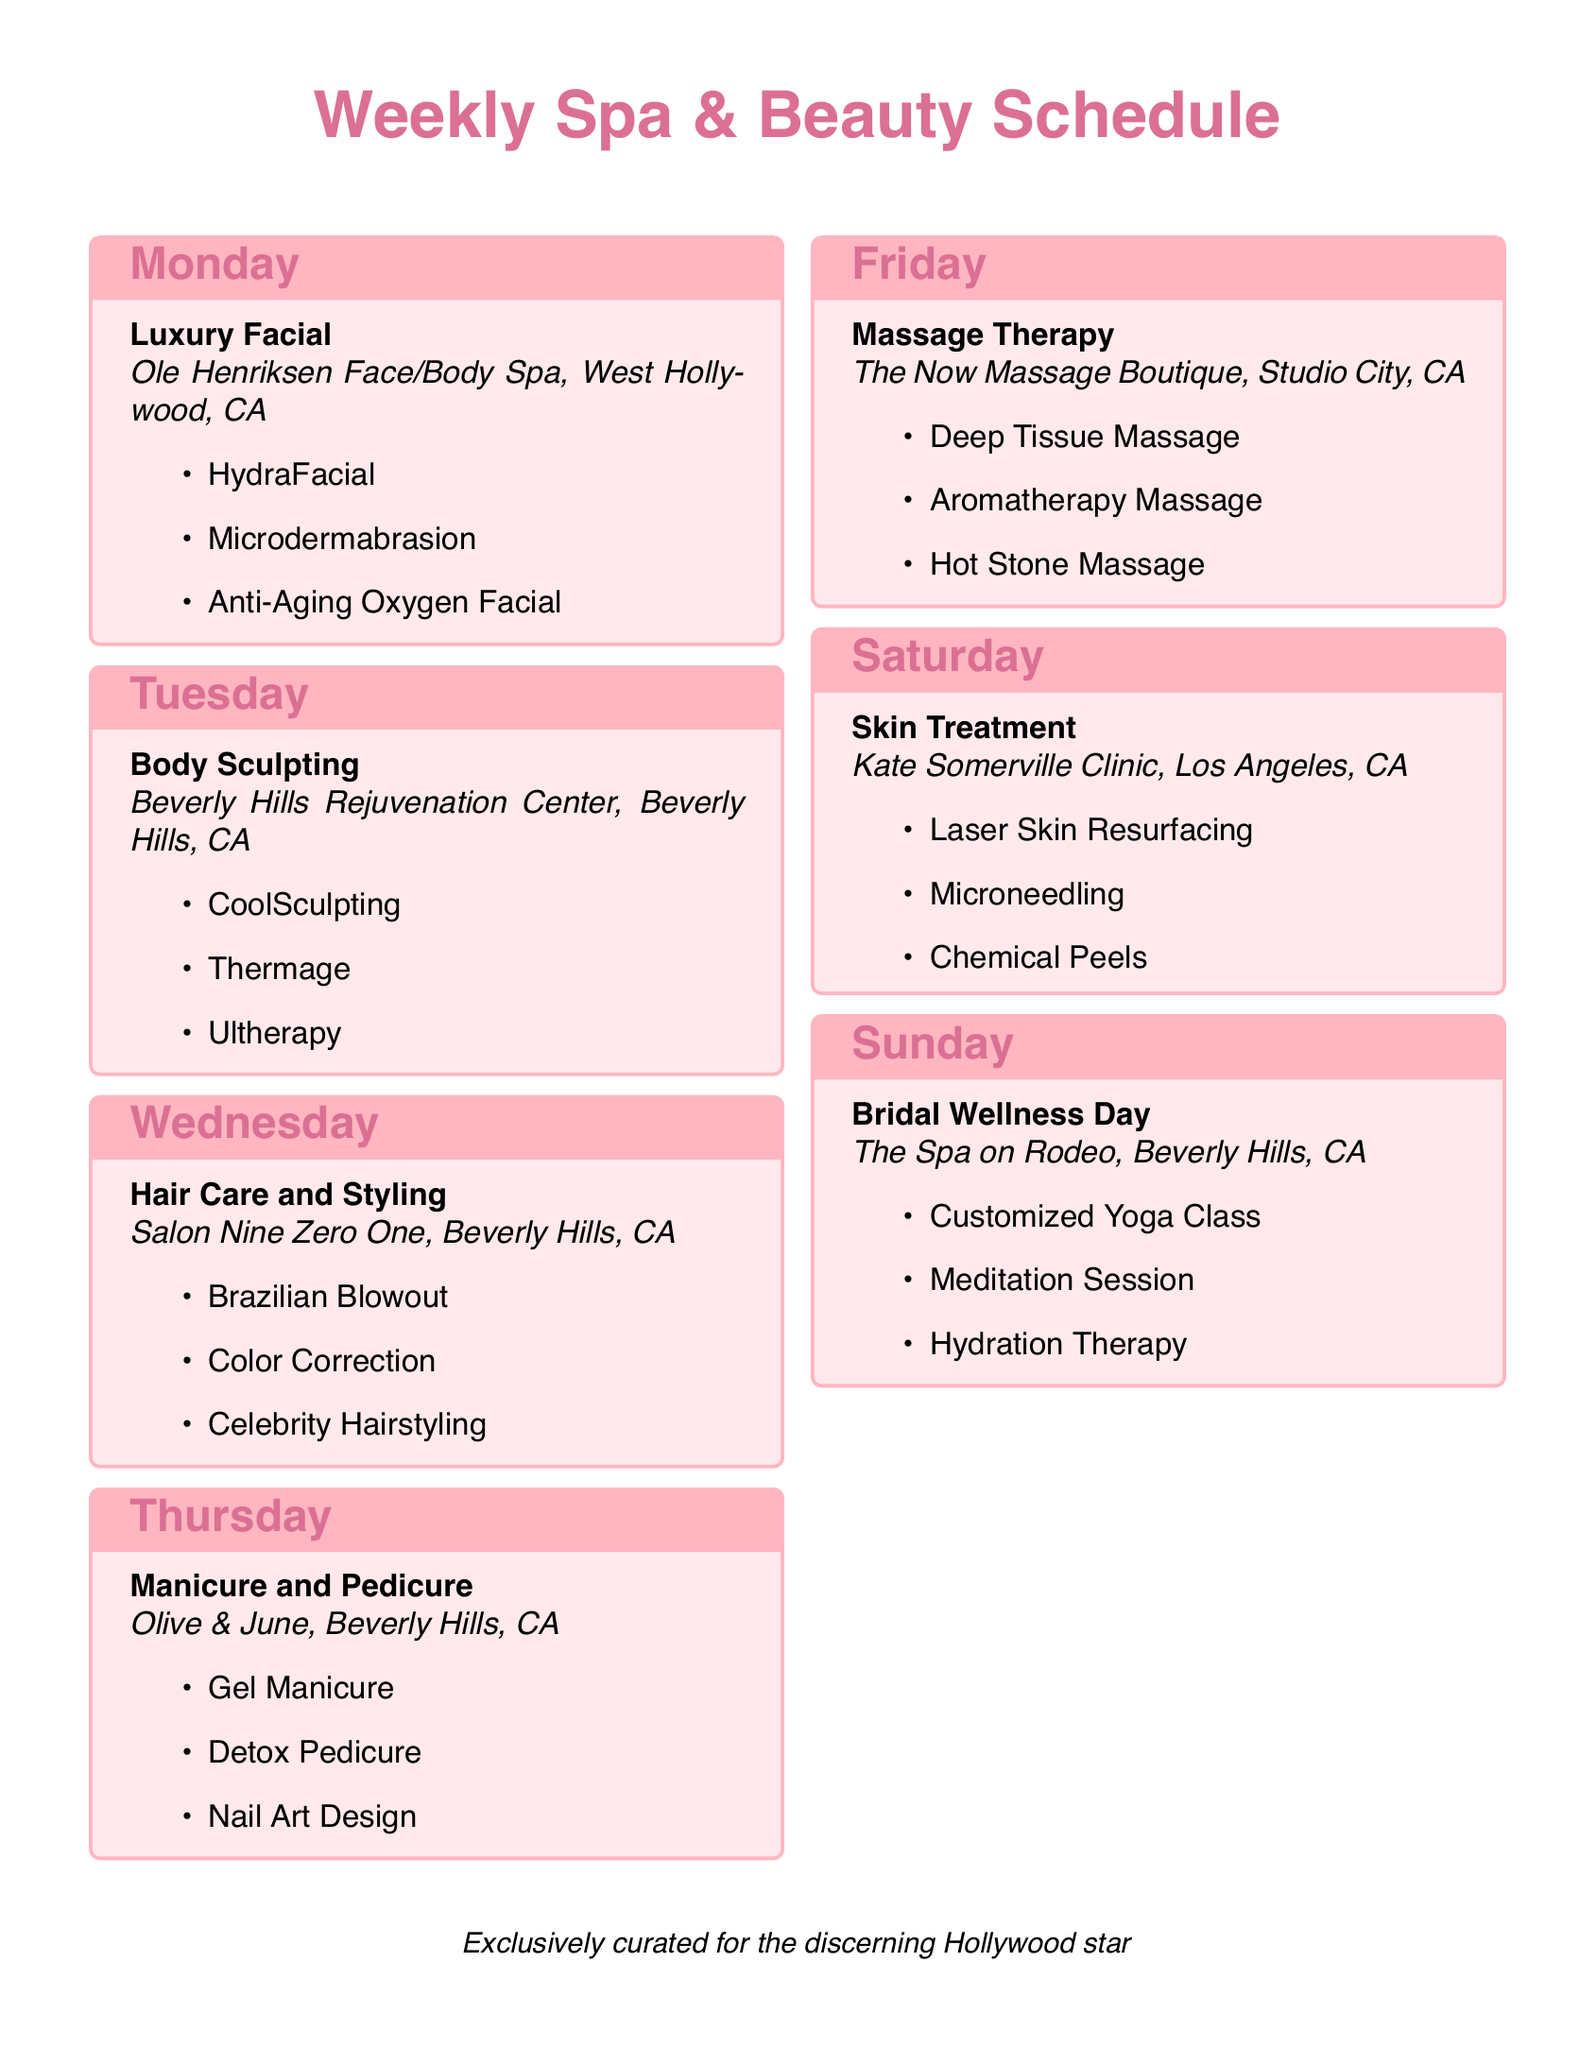what services are offered on Monday? Monday features a Luxury Facial, including HydraFacial, Microdermabrasion, and Anti-Aging Oxygen Facial.
Answer: Luxury Facial where is the Body Sculpting treatment located? The Body Sculpting treatment is at Beverly Hills Rejuvenation Center, Beverly Hills, CA.
Answer: Beverly Hills Rejuvenation Center which salon offers celebrity hairstyling? The salon that offers celebrity hairstyling is Salon Nine Zero One.
Answer: Salon Nine Zero One how many treatments are listed for Saturday? There are three treatments listed for Saturday: Laser Skin Resurfacing, Microneedling, and Chemical Peels.
Answer: Three which day is dedicated to bridal wellness? The day dedicated to bridal wellness is Sunday.
Answer: Sunday what type of massage is included on Friday? The massage types included on Friday are Deep Tissue Massage, Aromatherapy Massage, and Hot Stone Massage.
Answer: Massage Therapy which spa offers a customized yoga class? The spa that offers a customized yoga class is The Spa on Rodeo.
Answer: The Spa on Rodeo what color theme is used for the title? The color theme used for the title is a shade of pink (RGB 219,112,147).
Answer: Pink how many different salons are featured in the schedule? There are six different salons featured in the schedule.
Answer: Six 